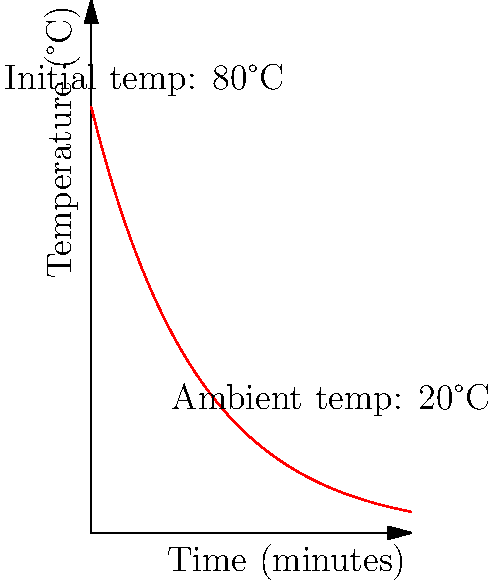You're storing a special package in a small, insulated container. The initial temperature inside is 80°C, and the ambient temperature outside is 20°C. If the temperature inside the container follows the cooling curve shown in the graph, after how many minutes will the temperature difference between the inside and outside of the container be reduced to 10°C? Let's approach this step-by-step:

1) The temperature inside the container at time $t$ is given by the equation:
   $T(t) = 80e^{-0.05t}$

2) We need to find $t$ when the temperature difference is 10°C. This means:
   $T(t) - 20 = 10$
   $T(t) = 30$

3) Substituting this into our equation:
   $30 = 80e^{-0.05t}$

4) Dividing both sides by 80:
   $\frac{3}{8} = e^{-0.05t}$

5) Taking the natural log of both sides:
   $\ln(\frac{3}{8}) = -0.05t$

6) Solving for $t$:
   $t = -\frac{\ln(\frac{3}{8})}{0.05}$

7) Calculating:
   $t \approx 46.05$ minutes

Therefore, it will take approximately 46 minutes for the temperature difference to reduce to 10°C.
Answer: 46 minutes 